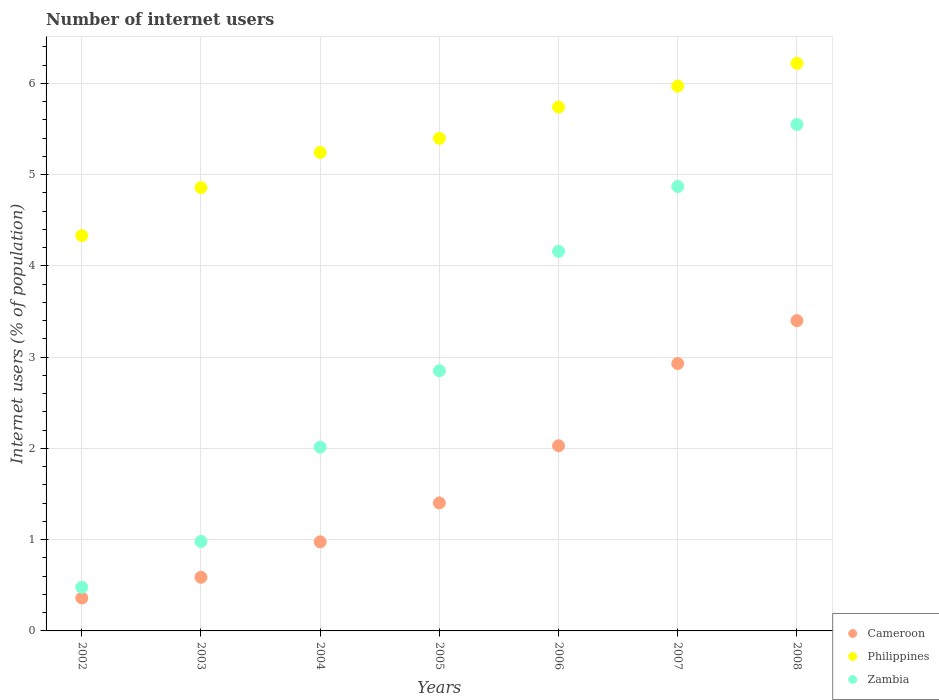Is the number of dotlines equal to the number of legend labels?
Offer a terse response. Yes. Across all years, what is the maximum number of internet users in Cameroon?
Provide a succinct answer. 3.4. Across all years, what is the minimum number of internet users in Philippines?
Offer a very short reply. 4.33. In which year was the number of internet users in Philippines maximum?
Provide a succinct answer. 2008. In which year was the number of internet users in Cameroon minimum?
Make the answer very short. 2002. What is the total number of internet users in Philippines in the graph?
Offer a very short reply. 37.76. What is the difference between the number of internet users in Cameroon in 2004 and that in 2006?
Offer a terse response. -1.05. What is the difference between the number of internet users in Zambia in 2004 and the number of internet users in Cameroon in 2003?
Offer a very short reply. 1.43. What is the average number of internet users in Zambia per year?
Your answer should be very brief. 2.99. In the year 2004, what is the difference between the number of internet users in Cameroon and number of internet users in Zambia?
Your answer should be very brief. -1.04. What is the ratio of the number of internet users in Philippines in 2004 to that in 2008?
Provide a succinct answer. 0.84. Is the number of internet users in Philippines in 2003 less than that in 2005?
Your answer should be very brief. Yes. What is the difference between the highest and the second highest number of internet users in Zambia?
Provide a short and direct response. 0.68. What is the difference between the highest and the lowest number of internet users in Philippines?
Offer a very short reply. 1.89. In how many years, is the number of internet users in Zambia greater than the average number of internet users in Zambia taken over all years?
Give a very brief answer. 3. Is the sum of the number of internet users in Philippines in 2002 and 2008 greater than the maximum number of internet users in Zambia across all years?
Ensure brevity in your answer.  Yes. Does the number of internet users in Cameroon monotonically increase over the years?
Make the answer very short. Yes. How many years are there in the graph?
Your answer should be compact. 7. What is the difference between two consecutive major ticks on the Y-axis?
Your response must be concise. 1. Does the graph contain any zero values?
Provide a succinct answer. No. Does the graph contain grids?
Offer a terse response. Yes. How are the legend labels stacked?
Your answer should be very brief. Vertical. What is the title of the graph?
Provide a succinct answer. Number of internet users. What is the label or title of the Y-axis?
Offer a terse response. Internet users (% of population). What is the Internet users (% of population) of Cameroon in 2002?
Offer a very short reply. 0.36. What is the Internet users (% of population) in Philippines in 2002?
Ensure brevity in your answer.  4.33. What is the Internet users (% of population) in Zambia in 2002?
Make the answer very short. 0.48. What is the Internet users (% of population) in Cameroon in 2003?
Your answer should be compact. 0.59. What is the Internet users (% of population) in Philippines in 2003?
Offer a terse response. 4.86. What is the Internet users (% of population) of Zambia in 2003?
Keep it short and to the point. 0.98. What is the Internet users (% of population) of Cameroon in 2004?
Ensure brevity in your answer.  0.98. What is the Internet users (% of population) in Philippines in 2004?
Keep it short and to the point. 5.24. What is the Internet users (% of population) of Zambia in 2004?
Your answer should be compact. 2.01. What is the Internet users (% of population) in Cameroon in 2005?
Your answer should be very brief. 1.4. What is the Internet users (% of population) in Philippines in 2005?
Keep it short and to the point. 5.4. What is the Internet users (% of population) of Zambia in 2005?
Your response must be concise. 2.85. What is the Internet users (% of population) in Cameroon in 2006?
Offer a terse response. 2.03. What is the Internet users (% of population) in Philippines in 2006?
Ensure brevity in your answer.  5.74. What is the Internet users (% of population) of Zambia in 2006?
Offer a terse response. 4.16. What is the Internet users (% of population) in Cameroon in 2007?
Provide a succinct answer. 2.93. What is the Internet users (% of population) of Philippines in 2007?
Offer a very short reply. 5.97. What is the Internet users (% of population) in Zambia in 2007?
Give a very brief answer. 4.87. What is the Internet users (% of population) of Philippines in 2008?
Give a very brief answer. 6.22. What is the Internet users (% of population) of Zambia in 2008?
Your answer should be very brief. 5.55. Across all years, what is the maximum Internet users (% of population) in Cameroon?
Your answer should be compact. 3.4. Across all years, what is the maximum Internet users (% of population) in Philippines?
Your answer should be very brief. 6.22. Across all years, what is the maximum Internet users (% of population) of Zambia?
Your answer should be very brief. 5.55. Across all years, what is the minimum Internet users (% of population) of Cameroon?
Provide a short and direct response. 0.36. Across all years, what is the minimum Internet users (% of population) of Philippines?
Offer a very short reply. 4.33. Across all years, what is the minimum Internet users (% of population) in Zambia?
Your answer should be very brief. 0.48. What is the total Internet users (% of population) in Cameroon in the graph?
Ensure brevity in your answer.  11.69. What is the total Internet users (% of population) in Philippines in the graph?
Provide a succinct answer. 37.76. What is the total Internet users (% of population) in Zambia in the graph?
Your answer should be compact. 20.9. What is the difference between the Internet users (% of population) in Cameroon in 2002 and that in 2003?
Your response must be concise. -0.23. What is the difference between the Internet users (% of population) in Philippines in 2002 and that in 2003?
Make the answer very short. -0.53. What is the difference between the Internet users (% of population) of Zambia in 2002 and that in 2003?
Give a very brief answer. -0.5. What is the difference between the Internet users (% of population) of Cameroon in 2002 and that in 2004?
Your answer should be compact. -0.62. What is the difference between the Internet users (% of population) of Philippines in 2002 and that in 2004?
Ensure brevity in your answer.  -0.91. What is the difference between the Internet users (% of population) in Zambia in 2002 and that in 2004?
Your answer should be compact. -1.54. What is the difference between the Internet users (% of population) in Cameroon in 2002 and that in 2005?
Make the answer very short. -1.04. What is the difference between the Internet users (% of population) in Philippines in 2002 and that in 2005?
Provide a succinct answer. -1.07. What is the difference between the Internet users (% of population) of Zambia in 2002 and that in 2005?
Offer a terse response. -2.37. What is the difference between the Internet users (% of population) of Cameroon in 2002 and that in 2006?
Give a very brief answer. -1.67. What is the difference between the Internet users (% of population) in Philippines in 2002 and that in 2006?
Ensure brevity in your answer.  -1.41. What is the difference between the Internet users (% of population) of Zambia in 2002 and that in 2006?
Your response must be concise. -3.68. What is the difference between the Internet users (% of population) of Cameroon in 2002 and that in 2007?
Provide a short and direct response. -2.57. What is the difference between the Internet users (% of population) in Philippines in 2002 and that in 2007?
Give a very brief answer. -1.64. What is the difference between the Internet users (% of population) of Zambia in 2002 and that in 2007?
Provide a succinct answer. -4.39. What is the difference between the Internet users (% of population) in Cameroon in 2002 and that in 2008?
Offer a very short reply. -3.04. What is the difference between the Internet users (% of population) in Philippines in 2002 and that in 2008?
Your answer should be very brief. -1.89. What is the difference between the Internet users (% of population) of Zambia in 2002 and that in 2008?
Offer a very short reply. -5.07. What is the difference between the Internet users (% of population) in Cameroon in 2003 and that in 2004?
Your response must be concise. -0.39. What is the difference between the Internet users (% of population) of Philippines in 2003 and that in 2004?
Your answer should be compact. -0.39. What is the difference between the Internet users (% of population) in Zambia in 2003 and that in 2004?
Offer a very short reply. -1.03. What is the difference between the Internet users (% of population) of Cameroon in 2003 and that in 2005?
Give a very brief answer. -0.81. What is the difference between the Internet users (% of population) of Philippines in 2003 and that in 2005?
Offer a terse response. -0.54. What is the difference between the Internet users (% of population) in Zambia in 2003 and that in 2005?
Your response must be concise. -1.87. What is the difference between the Internet users (% of population) of Cameroon in 2003 and that in 2006?
Ensure brevity in your answer.  -1.44. What is the difference between the Internet users (% of population) in Philippines in 2003 and that in 2006?
Your response must be concise. -0.88. What is the difference between the Internet users (% of population) of Zambia in 2003 and that in 2006?
Your response must be concise. -3.18. What is the difference between the Internet users (% of population) of Cameroon in 2003 and that in 2007?
Provide a succinct answer. -2.34. What is the difference between the Internet users (% of population) of Philippines in 2003 and that in 2007?
Offer a terse response. -1.11. What is the difference between the Internet users (% of population) of Zambia in 2003 and that in 2007?
Your answer should be very brief. -3.89. What is the difference between the Internet users (% of population) in Cameroon in 2003 and that in 2008?
Give a very brief answer. -2.81. What is the difference between the Internet users (% of population) of Philippines in 2003 and that in 2008?
Your response must be concise. -1.36. What is the difference between the Internet users (% of population) of Zambia in 2003 and that in 2008?
Offer a very short reply. -4.57. What is the difference between the Internet users (% of population) of Cameroon in 2004 and that in 2005?
Your answer should be compact. -0.43. What is the difference between the Internet users (% of population) of Philippines in 2004 and that in 2005?
Provide a succinct answer. -0.15. What is the difference between the Internet users (% of population) of Zambia in 2004 and that in 2005?
Give a very brief answer. -0.84. What is the difference between the Internet users (% of population) in Cameroon in 2004 and that in 2006?
Offer a very short reply. -1.05. What is the difference between the Internet users (% of population) in Philippines in 2004 and that in 2006?
Provide a short and direct response. -0.5. What is the difference between the Internet users (% of population) of Zambia in 2004 and that in 2006?
Your response must be concise. -2.15. What is the difference between the Internet users (% of population) of Cameroon in 2004 and that in 2007?
Provide a short and direct response. -1.95. What is the difference between the Internet users (% of population) of Philippines in 2004 and that in 2007?
Give a very brief answer. -0.73. What is the difference between the Internet users (% of population) in Zambia in 2004 and that in 2007?
Provide a short and direct response. -2.86. What is the difference between the Internet users (% of population) in Cameroon in 2004 and that in 2008?
Ensure brevity in your answer.  -2.42. What is the difference between the Internet users (% of population) of Philippines in 2004 and that in 2008?
Give a very brief answer. -0.98. What is the difference between the Internet users (% of population) in Zambia in 2004 and that in 2008?
Your response must be concise. -3.54. What is the difference between the Internet users (% of population) of Cameroon in 2005 and that in 2006?
Provide a succinct answer. -0.63. What is the difference between the Internet users (% of population) of Philippines in 2005 and that in 2006?
Keep it short and to the point. -0.34. What is the difference between the Internet users (% of population) in Zambia in 2005 and that in 2006?
Offer a terse response. -1.31. What is the difference between the Internet users (% of population) of Cameroon in 2005 and that in 2007?
Ensure brevity in your answer.  -1.53. What is the difference between the Internet users (% of population) of Philippines in 2005 and that in 2007?
Make the answer very short. -0.57. What is the difference between the Internet users (% of population) in Zambia in 2005 and that in 2007?
Provide a succinct answer. -2.02. What is the difference between the Internet users (% of population) in Cameroon in 2005 and that in 2008?
Provide a succinct answer. -2. What is the difference between the Internet users (% of population) in Philippines in 2005 and that in 2008?
Make the answer very short. -0.82. What is the difference between the Internet users (% of population) in Zambia in 2005 and that in 2008?
Offer a terse response. -2.7. What is the difference between the Internet users (% of population) in Cameroon in 2006 and that in 2007?
Your answer should be compact. -0.9. What is the difference between the Internet users (% of population) in Philippines in 2006 and that in 2007?
Your answer should be compact. -0.23. What is the difference between the Internet users (% of population) in Zambia in 2006 and that in 2007?
Your answer should be compact. -0.71. What is the difference between the Internet users (% of population) of Cameroon in 2006 and that in 2008?
Ensure brevity in your answer.  -1.37. What is the difference between the Internet users (% of population) in Philippines in 2006 and that in 2008?
Offer a very short reply. -0.48. What is the difference between the Internet users (% of population) of Zambia in 2006 and that in 2008?
Provide a short and direct response. -1.39. What is the difference between the Internet users (% of population) in Cameroon in 2007 and that in 2008?
Provide a succinct answer. -0.47. What is the difference between the Internet users (% of population) of Philippines in 2007 and that in 2008?
Your answer should be compact. -0.25. What is the difference between the Internet users (% of population) in Zambia in 2007 and that in 2008?
Make the answer very short. -0.68. What is the difference between the Internet users (% of population) of Cameroon in 2002 and the Internet users (% of population) of Philippines in 2003?
Your answer should be compact. -4.5. What is the difference between the Internet users (% of population) in Cameroon in 2002 and the Internet users (% of population) in Zambia in 2003?
Provide a succinct answer. -0.62. What is the difference between the Internet users (% of population) in Philippines in 2002 and the Internet users (% of population) in Zambia in 2003?
Your response must be concise. 3.35. What is the difference between the Internet users (% of population) in Cameroon in 2002 and the Internet users (% of population) in Philippines in 2004?
Provide a short and direct response. -4.88. What is the difference between the Internet users (% of population) in Cameroon in 2002 and the Internet users (% of population) in Zambia in 2004?
Give a very brief answer. -1.65. What is the difference between the Internet users (% of population) in Philippines in 2002 and the Internet users (% of population) in Zambia in 2004?
Give a very brief answer. 2.32. What is the difference between the Internet users (% of population) of Cameroon in 2002 and the Internet users (% of population) of Philippines in 2005?
Your response must be concise. -5.04. What is the difference between the Internet users (% of population) of Cameroon in 2002 and the Internet users (% of population) of Zambia in 2005?
Your response must be concise. -2.49. What is the difference between the Internet users (% of population) of Philippines in 2002 and the Internet users (% of population) of Zambia in 2005?
Make the answer very short. 1.48. What is the difference between the Internet users (% of population) in Cameroon in 2002 and the Internet users (% of population) in Philippines in 2006?
Provide a succinct answer. -5.38. What is the difference between the Internet users (% of population) of Cameroon in 2002 and the Internet users (% of population) of Zambia in 2006?
Make the answer very short. -3.8. What is the difference between the Internet users (% of population) in Philippines in 2002 and the Internet users (% of population) in Zambia in 2006?
Provide a short and direct response. 0.17. What is the difference between the Internet users (% of population) in Cameroon in 2002 and the Internet users (% of population) in Philippines in 2007?
Keep it short and to the point. -5.61. What is the difference between the Internet users (% of population) in Cameroon in 2002 and the Internet users (% of population) in Zambia in 2007?
Give a very brief answer. -4.51. What is the difference between the Internet users (% of population) in Philippines in 2002 and the Internet users (% of population) in Zambia in 2007?
Make the answer very short. -0.54. What is the difference between the Internet users (% of population) of Cameroon in 2002 and the Internet users (% of population) of Philippines in 2008?
Offer a very short reply. -5.86. What is the difference between the Internet users (% of population) in Cameroon in 2002 and the Internet users (% of population) in Zambia in 2008?
Offer a very short reply. -5.19. What is the difference between the Internet users (% of population) in Philippines in 2002 and the Internet users (% of population) in Zambia in 2008?
Offer a very short reply. -1.22. What is the difference between the Internet users (% of population) of Cameroon in 2003 and the Internet users (% of population) of Philippines in 2004?
Provide a short and direct response. -4.66. What is the difference between the Internet users (% of population) in Cameroon in 2003 and the Internet users (% of population) in Zambia in 2004?
Make the answer very short. -1.43. What is the difference between the Internet users (% of population) of Philippines in 2003 and the Internet users (% of population) of Zambia in 2004?
Provide a short and direct response. 2.84. What is the difference between the Internet users (% of population) in Cameroon in 2003 and the Internet users (% of population) in Philippines in 2005?
Make the answer very short. -4.81. What is the difference between the Internet users (% of population) of Cameroon in 2003 and the Internet users (% of population) of Zambia in 2005?
Give a very brief answer. -2.26. What is the difference between the Internet users (% of population) of Philippines in 2003 and the Internet users (% of population) of Zambia in 2005?
Offer a very short reply. 2.01. What is the difference between the Internet users (% of population) in Cameroon in 2003 and the Internet users (% of population) in Philippines in 2006?
Offer a very short reply. -5.15. What is the difference between the Internet users (% of population) of Cameroon in 2003 and the Internet users (% of population) of Zambia in 2006?
Give a very brief answer. -3.57. What is the difference between the Internet users (% of population) of Philippines in 2003 and the Internet users (% of population) of Zambia in 2006?
Offer a very short reply. 0.7. What is the difference between the Internet users (% of population) in Cameroon in 2003 and the Internet users (% of population) in Philippines in 2007?
Give a very brief answer. -5.38. What is the difference between the Internet users (% of population) of Cameroon in 2003 and the Internet users (% of population) of Zambia in 2007?
Provide a succinct answer. -4.28. What is the difference between the Internet users (% of population) of Philippines in 2003 and the Internet users (% of population) of Zambia in 2007?
Provide a short and direct response. -0.01. What is the difference between the Internet users (% of population) of Cameroon in 2003 and the Internet users (% of population) of Philippines in 2008?
Your answer should be compact. -5.63. What is the difference between the Internet users (% of population) in Cameroon in 2003 and the Internet users (% of population) in Zambia in 2008?
Give a very brief answer. -4.96. What is the difference between the Internet users (% of population) in Philippines in 2003 and the Internet users (% of population) in Zambia in 2008?
Provide a succinct answer. -0.69. What is the difference between the Internet users (% of population) of Cameroon in 2004 and the Internet users (% of population) of Philippines in 2005?
Provide a short and direct response. -4.42. What is the difference between the Internet users (% of population) in Cameroon in 2004 and the Internet users (% of population) in Zambia in 2005?
Give a very brief answer. -1.88. What is the difference between the Internet users (% of population) in Philippines in 2004 and the Internet users (% of population) in Zambia in 2005?
Provide a succinct answer. 2.39. What is the difference between the Internet users (% of population) of Cameroon in 2004 and the Internet users (% of population) of Philippines in 2006?
Your answer should be very brief. -4.76. What is the difference between the Internet users (% of population) in Cameroon in 2004 and the Internet users (% of population) in Zambia in 2006?
Offer a terse response. -3.18. What is the difference between the Internet users (% of population) in Philippines in 2004 and the Internet users (% of population) in Zambia in 2006?
Give a very brief answer. 1.08. What is the difference between the Internet users (% of population) of Cameroon in 2004 and the Internet users (% of population) of Philippines in 2007?
Give a very brief answer. -4.99. What is the difference between the Internet users (% of population) of Cameroon in 2004 and the Internet users (% of population) of Zambia in 2007?
Provide a short and direct response. -3.89. What is the difference between the Internet users (% of population) of Philippines in 2004 and the Internet users (% of population) of Zambia in 2007?
Provide a short and direct response. 0.37. What is the difference between the Internet users (% of population) of Cameroon in 2004 and the Internet users (% of population) of Philippines in 2008?
Give a very brief answer. -5.24. What is the difference between the Internet users (% of population) of Cameroon in 2004 and the Internet users (% of population) of Zambia in 2008?
Provide a short and direct response. -4.57. What is the difference between the Internet users (% of population) of Philippines in 2004 and the Internet users (% of population) of Zambia in 2008?
Your response must be concise. -0.31. What is the difference between the Internet users (% of population) in Cameroon in 2005 and the Internet users (% of population) in Philippines in 2006?
Provide a succinct answer. -4.34. What is the difference between the Internet users (% of population) in Cameroon in 2005 and the Internet users (% of population) in Zambia in 2006?
Offer a very short reply. -2.76. What is the difference between the Internet users (% of population) of Philippines in 2005 and the Internet users (% of population) of Zambia in 2006?
Offer a very short reply. 1.24. What is the difference between the Internet users (% of population) of Cameroon in 2005 and the Internet users (% of population) of Philippines in 2007?
Provide a short and direct response. -4.57. What is the difference between the Internet users (% of population) in Cameroon in 2005 and the Internet users (% of population) in Zambia in 2007?
Provide a succinct answer. -3.47. What is the difference between the Internet users (% of population) of Philippines in 2005 and the Internet users (% of population) of Zambia in 2007?
Offer a terse response. 0.53. What is the difference between the Internet users (% of population) in Cameroon in 2005 and the Internet users (% of population) in Philippines in 2008?
Provide a short and direct response. -4.82. What is the difference between the Internet users (% of population) of Cameroon in 2005 and the Internet users (% of population) of Zambia in 2008?
Your response must be concise. -4.15. What is the difference between the Internet users (% of population) in Philippines in 2005 and the Internet users (% of population) in Zambia in 2008?
Your answer should be compact. -0.15. What is the difference between the Internet users (% of population) in Cameroon in 2006 and the Internet users (% of population) in Philippines in 2007?
Your answer should be compact. -3.94. What is the difference between the Internet users (% of population) of Cameroon in 2006 and the Internet users (% of population) of Zambia in 2007?
Provide a short and direct response. -2.84. What is the difference between the Internet users (% of population) in Philippines in 2006 and the Internet users (% of population) in Zambia in 2007?
Ensure brevity in your answer.  0.87. What is the difference between the Internet users (% of population) in Cameroon in 2006 and the Internet users (% of population) in Philippines in 2008?
Your answer should be compact. -4.19. What is the difference between the Internet users (% of population) of Cameroon in 2006 and the Internet users (% of population) of Zambia in 2008?
Provide a short and direct response. -3.52. What is the difference between the Internet users (% of population) in Philippines in 2006 and the Internet users (% of population) in Zambia in 2008?
Provide a short and direct response. 0.19. What is the difference between the Internet users (% of population) in Cameroon in 2007 and the Internet users (% of population) in Philippines in 2008?
Your answer should be very brief. -3.29. What is the difference between the Internet users (% of population) of Cameroon in 2007 and the Internet users (% of population) of Zambia in 2008?
Your answer should be very brief. -2.62. What is the difference between the Internet users (% of population) in Philippines in 2007 and the Internet users (% of population) in Zambia in 2008?
Your answer should be very brief. 0.42. What is the average Internet users (% of population) of Cameroon per year?
Make the answer very short. 1.67. What is the average Internet users (% of population) in Philippines per year?
Ensure brevity in your answer.  5.39. What is the average Internet users (% of population) of Zambia per year?
Ensure brevity in your answer.  2.99. In the year 2002, what is the difference between the Internet users (% of population) in Cameroon and Internet users (% of population) in Philippines?
Provide a succinct answer. -3.97. In the year 2002, what is the difference between the Internet users (% of population) of Cameroon and Internet users (% of population) of Zambia?
Offer a very short reply. -0.12. In the year 2002, what is the difference between the Internet users (% of population) in Philippines and Internet users (% of population) in Zambia?
Offer a terse response. 3.85. In the year 2003, what is the difference between the Internet users (% of population) in Cameroon and Internet users (% of population) in Philippines?
Your answer should be compact. -4.27. In the year 2003, what is the difference between the Internet users (% of population) of Cameroon and Internet users (% of population) of Zambia?
Your response must be concise. -0.39. In the year 2003, what is the difference between the Internet users (% of population) of Philippines and Internet users (% of population) of Zambia?
Make the answer very short. 3.88. In the year 2004, what is the difference between the Internet users (% of population) in Cameroon and Internet users (% of population) in Philippines?
Your response must be concise. -4.27. In the year 2004, what is the difference between the Internet users (% of population) of Cameroon and Internet users (% of population) of Zambia?
Ensure brevity in your answer.  -1.04. In the year 2004, what is the difference between the Internet users (% of population) of Philippines and Internet users (% of population) of Zambia?
Provide a short and direct response. 3.23. In the year 2005, what is the difference between the Internet users (% of population) in Cameroon and Internet users (% of population) in Philippines?
Your response must be concise. -4. In the year 2005, what is the difference between the Internet users (% of population) in Cameroon and Internet users (% of population) in Zambia?
Keep it short and to the point. -1.45. In the year 2005, what is the difference between the Internet users (% of population) of Philippines and Internet users (% of population) of Zambia?
Keep it short and to the point. 2.55. In the year 2006, what is the difference between the Internet users (% of population) of Cameroon and Internet users (% of population) of Philippines?
Make the answer very short. -3.71. In the year 2006, what is the difference between the Internet users (% of population) in Cameroon and Internet users (% of population) in Zambia?
Offer a terse response. -2.13. In the year 2006, what is the difference between the Internet users (% of population) in Philippines and Internet users (% of population) in Zambia?
Keep it short and to the point. 1.58. In the year 2007, what is the difference between the Internet users (% of population) of Cameroon and Internet users (% of population) of Philippines?
Your answer should be very brief. -3.04. In the year 2007, what is the difference between the Internet users (% of population) of Cameroon and Internet users (% of population) of Zambia?
Offer a very short reply. -1.94. In the year 2008, what is the difference between the Internet users (% of population) in Cameroon and Internet users (% of population) in Philippines?
Your answer should be compact. -2.82. In the year 2008, what is the difference between the Internet users (% of population) in Cameroon and Internet users (% of population) in Zambia?
Keep it short and to the point. -2.15. In the year 2008, what is the difference between the Internet users (% of population) in Philippines and Internet users (% of population) in Zambia?
Make the answer very short. 0.67. What is the ratio of the Internet users (% of population) in Cameroon in 2002 to that in 2003?
Your answer should be compact. 0.61. What is the ratio of the Internet users (% of population) of Philippines in 2002 to that in 2003?
Your response must be concise. 0.89. What is the ratio of the Internet users (% of population) in Zambia in 2002 to that in 2003?
Your answer should be very brief. 0.49. What is the ratio of the Internet users (% of population) in Cameroon in 2002 to that in 2004?
Offer a terse response. 0.37. What is the ratio of the Internet users (% of population) of Philippines in 2002 to that in 2004?
Keep it short and to the point. 0.83. What is the ratio of the Internet users (% of population) of Zambia in 2002 to that in 2004?
Offer a very short reply. 0.24. What is the ratio of the Internet users (% of population) in Cameroon in 2002 to that in 2005?
Offer a terse response. 0.26. What is the ratio of the Internet users (% of population) of Philippines in 2002 to that in 2005?
Provide a short and direct response. 0.8. What is the ratio of the Internet users (% of population) in Zambia in 2002 to that in 2005?
Your answer should be very brief. 0.17. What is the ratio of the Internet users (% of population) in Cameroon in 2002 to that in 2006?
Make the answer very short. 0.18. What is the ratio of the Internet users (% of population) in Philippines in 2002 to that in 2006?
Keep it short and to the point. 0.75. What is the ratio of the Internet users (% of population) of Zambia in 2002 to that in 2006?
Your answer should be compact. 0.11. What is the ratio of the Internet users (% of population) of Cameroon in 2002 to that in 2007?
Ensure brevity in your answer.  0.12. What is the ratio of the Internet users (% of population) in Philippines in 2002 to that in 2007?
Provide a succinct answer. 0.73. What is the ratio of the Internet users (% of population) of Zambia in 2002 to that in 2007?
Ensure brevity in your answer.  0.1. What is the ratio of the Internet users (% of population) in Cameroon in 2002 to that in 2008?
Your response must be concise. 0.11. What is the ratio of the Internet users (% of population) of Philippines in 2002 to that in 2008?
Offer a terse response. 0.7. What is the ratio of the Internet users (% of population) of Zambia in 2002 to that in 2008?
Keep it short and to the point. 0.09. What is the ratio of the Internet users (% of population) in Cameroon in 2003 to that in 2004?
Your answer should be very brief. 0.6. What is the ratio of the Internet users (% of population) of Philippines in 2003 to that in 2004?
Give a very brief answer. 0.93. What is the ratio of the Internet users (% of population) in Zambia in 2003 to that in 2004?
Provide a short and direct response. 0.49. What is the ratio of the Internet users (% of population) of Cameroon in 2003 to that in 2005?
Ensure brevity in your answer.  0.42. What is the ratio of the Internet users (% of population) in Zambia in 2003 to that in 2005?
Your response must be concise. 0.34. What is the ratio of the Internet users (% of population) of Cameroon in 2003 to that in 2006?
Offer a very short reply. 0.29. What is the ratio of the Internet users (% of population) in Philippines in 2003 to that in 2006?
Your response must be concise. 0.85. What is the ratio of the Internet users (% of population) in Zambia in 2003 to that in 2006?
Offer a very short reply. 0.24. What is the ratio of the Internet users (% of population) in Cameroon in 2003 to that in 2007?
Make the answer very short. 0.2. What is the ratio of the Internet users (% of population) of Philippines in 2003 to that in 2007?
Your answer should be compact. 0.81. What is the ratio of the Internet users (% of population) in Zambia in 2003 to that in 2007?
Your answer should be very brief. 0.2. What is the ratio of the Internet users (% of population) in Cameroon in 2003 to that in 2008?
Keep it short and to the point. 0.17. What is the ratio of the Internet users (% of population) of Philippines in 2003 to that in 2008?
Provide a succinct answer. 0.78. What is the ratio of the Internet users (% of population) of Zambia in 2003 to that in 2008?
Make the answer very short. 0.18. What is the ratio of the Internet users (% of population) of Cameroon in 2004 to that in 2005?
Keep it short and to the point. 0.7. What is the ratio of the Internet users (% of population) of Philippines in 2004 to that in 2005?
Provide a succinct answer. 0.97. What is the ratio of the Internet users (% of population) in Zambia in 2004 to that in 2005?
Keep it short and to the point. 0.71. What is the ratio of the Internet users (% of population) of Cameroon in 2004 to that in 2006?
Your answer should be very brief. 0.48. What is the ratio of the Internet users (% of population) in Philippines in 2004 to that in 2006?
Make the answer very short. 0.91. What is the ratio of the Internet users (% of population) of Zambia in 2004 to that in 2006?
Provide a short and direct response. 0.48. What is the ratio of the Internet users (% of population) of Cameroon in 2004 to that in 2007?
Provide a short and direct response. 0.33. What is the ratio of the Internet users (% of population) in Philippines in 2004 to that in 2007?
Your answer should be very brief. 0.88. What is the ratio of the Internet users (% of population) of Zambia in 2004 to that in 2007?
Offer a terse response. 0.41. What is the ratio of the Internet users (% of population) in Cameroon in 2004 to that in 2008?
Provide a succinct answer. 0.29. What is the ratio of the Internet users (% of population) in Philippines in 2004 to that in 2008?
Your answer should be compact. 0.84. What is the ratio of the Internet users (% of population) of Zambia in 2004 to that in 2008?
Give a very brief answer. 0.36. What is the ratio of the Internet users (% of population) in Cameroon in 2005 to that in 2006?
Your response must be concise. 0.69. What is the ratio of the Internet users (% of population) of Philippines in 2005 to that in 2006?
Provide a short and direct response. 0.94. What is the ratio of the Internet users (% of population) in Zambia in 2005 to that in 2006?
Offer a very short reply. 0.69. What is the ratio of the Internet users (% of population) of Cameroon in 2005 to that in 2007?
Offer a terse response. 0.48. What is the ratio of the Internet users (% of population) of Philippines in 2005 to that in 2007?
Provide a succinct answer. 0.9. What is the ratio of the Internet users (% of population) of Zambia in 2005 to that in 2007?
Provide a short and direct response. 0.59. What is the ratio of the Internet users (% of population) in Cameroon in 2005 to that in 2008?
Ensure brevity in your answer.  0.41. What is the ratio of the Internet users (% of population) in Philippines in 2005 to that in 2008?
Offer a terse response. 0.87. What is the ratio of the Internet users (% of population) in Zambia in 2005 to that in 2008?
Your answer should be compact. 0.51. What is the ratio of the Internet users (% of population) of Cameroon in 2006 to that in 2007?
Ensure brevity in your answer.  0.69. What is the ratio of the Internet users (% of population) in Philippines in 2006 to that in 2007?
Provide a succinct answer. 0.96. What is the ratio of the Internet users (% of population) of Zambia in 2006 to that in 2007?
Your answer should be compact. 0.85. What is the ratio of the Internet users (% of population) of Cameroon in 2006 to that in 2008?
Make the answer very short. 0.6. What is the ratio of the Internet users (% of population) of Philippines in 2006 to that in 2008?
Offer a very short reply. 0.92. What is the ratio of the Internet users (% of population) of Zambia in 2006 to that in 2008?
Provide a short and direct response. 0.75. What is the ratio of the Internet users (% of population) in Cameroon in 2007 to that in 2008?
Your answer should be very brief. 0.86. What is the ratio of the Internet users (% of population) of Philippines in 2007 to that in 2008?
Provide a succinct answer. 0.96. What is the ratio of the Internet users (% of population) in Zambia in 2007 to that in 2008?
Your answer should be very brief. 0.88. What is the difference between the highest and the second highest Internet users (% of population) of Cameroon?
Your answer should be very brief. 0.47. What is the difference between the highest and the second highest Internet users (% of population) of Zambia?
Provide a short and direct response. 0.68. What is the difference between the highest and the lowest Internet users (% of population) in Cameroon?
Offer a very short reply. 3.04. What is the difference between the highest and the lowest Internet users (% of population) of Philippines?
Give a very brief answer. 1.89. What is the difference between the highest and the lowest Internet users (% of population) in Zambia?
Make the answer very short. 5.07. 